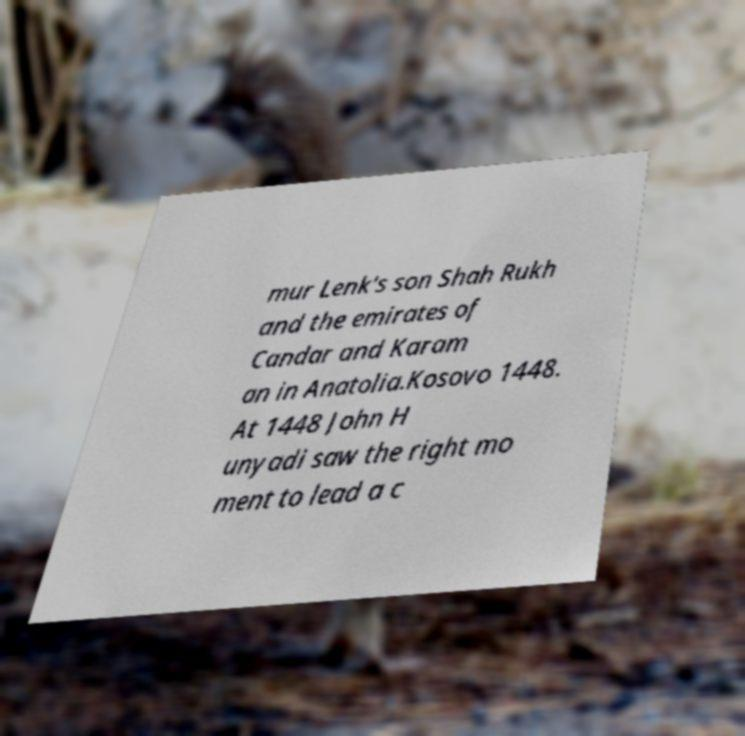Please identify and transcribe the text found in this image. mur Lenk's son Shah Rukh and the emirates of Candar and Karam an in Anatolia.Kosovo 1448. At 1448 John H unyadi saw the right mo ment to lead a c 